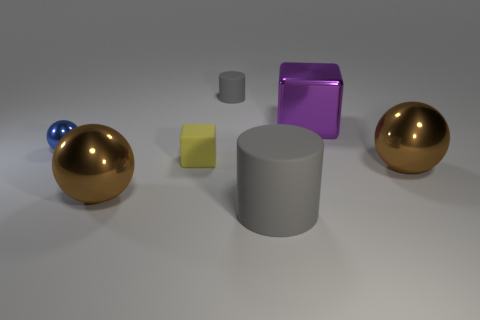What number of brown objects are either rubber objects or rubber balls?
Your answer should be very brief. 0. Are there more tiny rubber blocks than large brown shiny spheres?
Offer a terse response. No. What number of things are either metallic spheres left of the big purple metallic cube or shiny things left of the big block?
Your answer should be very brief. 2. What color is the rubber cylinder that is the same size as the blue shiny thing?
Your answer should be compact. Gray. Is the material of the big gray cylinder the same as the yellow object?
Provide a short and direct response. Yes. There is a large brown object that is on the left side of the metal sphere that is on the right side of the large gray cylinder; what is it made of?
Make the answer very short. Metal. Are there more large brown objects on the right side of the big gray rubber thing than red shiny cylinders?
Keep it short and to the point. Yes. What number of other things are there of the same size as the purple metal thing?
Give a very brief answer. 3. Is the color of the large rubber cylinder the same as the small matte cylinder?
Provide a succinct answer. Yes. The block that is behind the rubber thing that is left of the rubber cylinder that is behind the purple cube is what color?
Provide a succinct answer. Purple. 